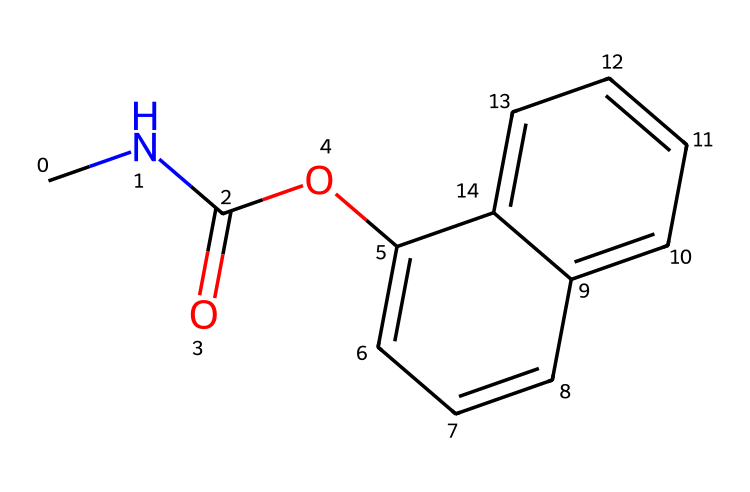How many carbon atoms are in carbaryl? By analyzing the SMILES representation, we can identify each carbon atom represented by 'C' and count them. In the structure, there are 10 carbon atoms shown in the molecular formula.
Answer: 10 What functional group is present in carbaryl? The SMILES notation contains a 'C(=O)' which indicates a carbon atom double-bonded to an oxygen atom, representing a carbonyl group. Additionally, the presence of 'O' connected to an aromatic ring indicates it's part of an ester.
Answer: carbonyl How many aromatic rings does carbaryl contain? When examining the SMILES structure, both 'c' and 'C' indicate aromatic and non-aromatic carbon atoms, respectively. There are two distinct aromatic rings in the structure that are interconnected.
Answer: 2 What is the total number of nitrogen atoms in carbaryl? The SMILES representation includes a 'N', indicating one nitrogen atom present in the structure of carbaryl. Counting the occurrences gives us the total number.
Answer: 1 What type of pesticide is carbaryl classified as? Carbaryl, based on its molecular structure and usage, falls under the category of carbamate insecticides. The presence of the carbamate functional group defines it within this class.
Answer: carbamate 